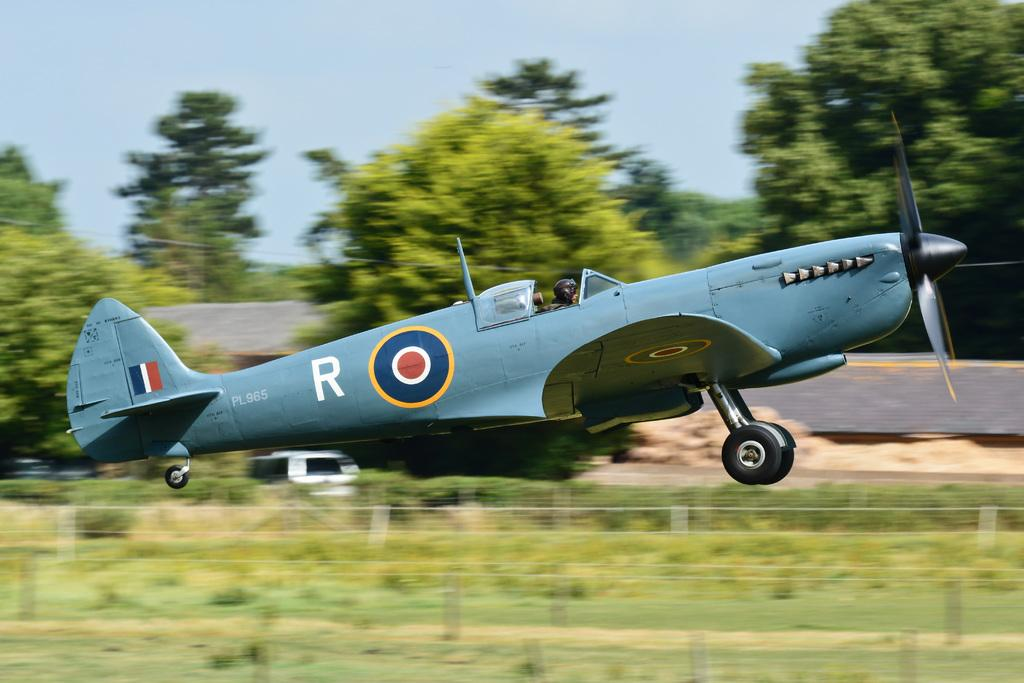What is the main subject of the image? The main subject of the image is an airplane flying in the air. What type of natural environment is visible in the image? There is grass and trees visible in the image. What is visible in the background of the image? The sky is visible in the background of the image. Can you tell me how many pins are holding the donkey's ears in the image? There is no donkey or pins present in the image. 